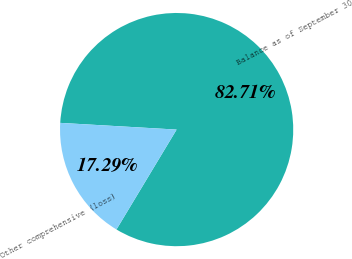<chart> <loc_0><loc_0><loc_500><loc_500><pie_chart><fcel>Balance as of September 30<fcel>Other comprehensive (loss)<nl><fcel>82.71%<fcel>17.29%<nl></chart> 